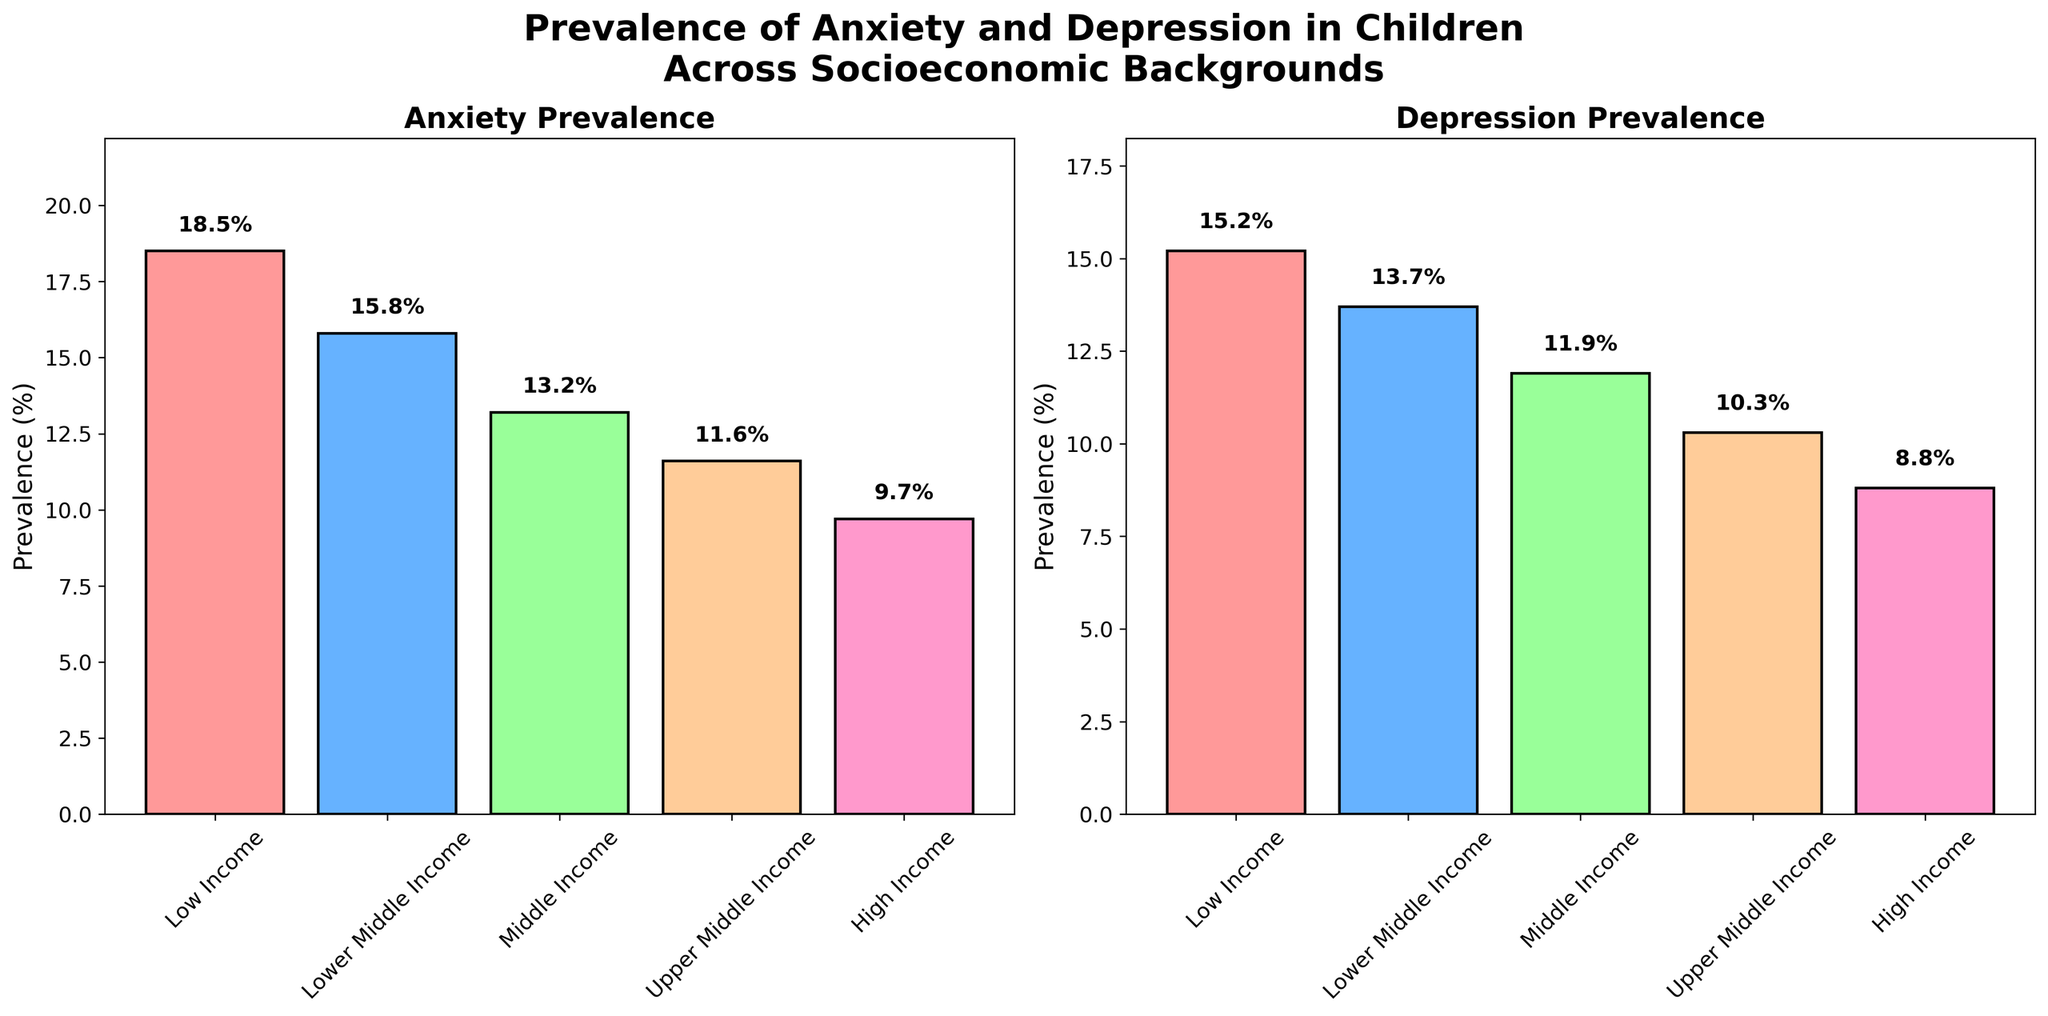Which socioeconomic group has the highest prevalence of anxiety in children? The first plot shows the prevalence of anxiety in children across different socioeconomic groups. By comparing the heights of the bars, the "Low Income" group has the tallest bar, indicating the highest prevalence.
Answer: Low Income What is the prevalence difference between anxiety and depression in the "Lower Middle Income" group? In the "Lower Middle Income" category, the anxiety prevalence is 15.8% and the depression prevalence is 13.7%. The difference is calculated by subtracting 13.7 from 15.8 (15.8 - 13.7 = 2.1).
Answer: 2.1% Which socioeconomic group has the lowest prevalence of depression in children? Again, we look at the second plot, where the bars represent depression prevalence. The "High Income" group has the shortest bar, indicating the lowest prevalence of depression.
Answer: High Income How does the prevalence of anxiety in "Upper Middle Income" compare to that in "Middle Income"? By comparing the heights of the bars for these two groups in the anxiety plot, the "Upper Middle Income" group has a prevalence of 11.6%, while the "Middle Income" group has a prevalence of 13.2%. "Upper Middle Income" has a lower prevalence.
Answer: Upper Middle Income < Middle Income What is the average prevalence of depression in children across all socioeconomic backgrounds? The depression prevalences are 15.2%, 13.7%, 11.9%, 10.3%, and 8.8%. Summing these values (15.2 + 13.7 + 11.9 + 10.3 + 8.8 = 59.9) and dividing by the number of groups (5) gives the average (59.9 / 5 = 11.98).
Answer: 11.98% Which color represents the "Middle Income" group in the anxiety plot? The anxiety plot uses colors to represent different socioeconomic groups. By counting bars from left to right, the "Middle Income" group is the third bar. The color of this bar, as indicated, is green.
Answer: Green How much higher is the highest anxiety prevalence compared to the lowest? The highest anxiety prevalence is in the "Low Income" group at 18.5%, and the lowest is in the "High Income" group at 9.7%. Subtracting 9.7 from 18.5 (18.5 - 9.7 = 8.8) gives the difference.
Answer: 8.8% Is the prevalence of anxiety always higher than that of depression for every socioeconomic group? By comparing the corresponding bars for anxiety and depression in each socioeconomic group, we see that in every group, the anxiety bar is taller than the depression bar, meaning anxiety prevalence is higher than depression prevalence.
Answer: Yes What is the overall trend in both anxiety and depression prevalence as socioeconomic status increases? Observing both plots, the heights of the bars for anxiety and depression generally decrease as we move from left (Low Income) to right (High Income), indicating that prevalence of both conditions decreases with higher socioeconomic status.
Answer: Decreases If you add the anxiety and depression prevalences for the "High Income" group, what would be the total? The anxiety prevalence for the "High Income" group is 9.7%, and the depression prevalence is 8.8%. Adding these gives (9.7 + 8.8 = 18.5).
Answer: 18.5% 